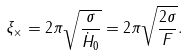Convert formula to latex. <formula><loc_0><loc_0><loc_500><loc_500>\xi _ { \times } = 2 \pi \sqrt { \frac { \sigma } { \dot { H } _ { 0 } } } = 2 \pi \sqrt { \frac { 2 \sigma } { F } } .</formula> 